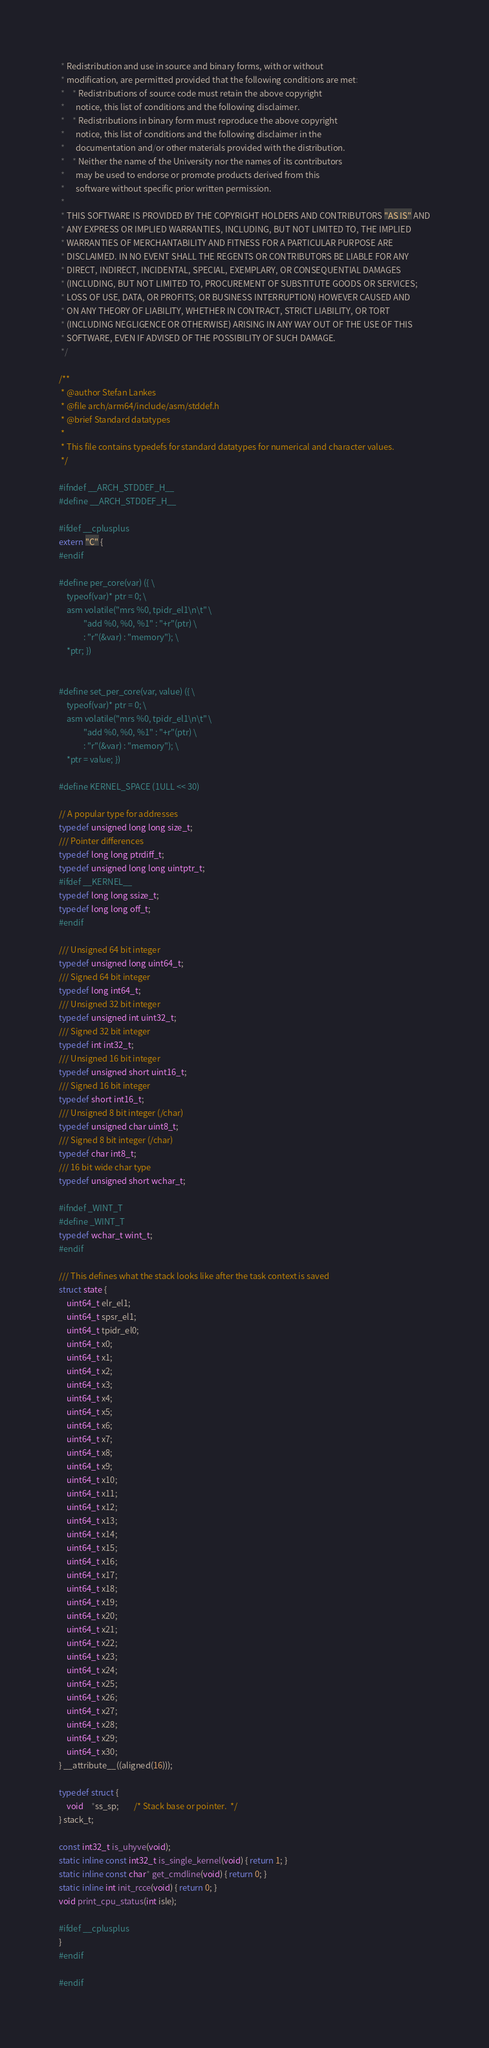<code> <loc_0><loc_0><loc_500><loc_500><_C_> * Redistribution and use in source and binary forms, with or without
 * modification, are permitted provided that the following conditions are met:
 *    * Redistributions of source code must retain the above copyright
 *      notice, this list of conditions and the following disclaimer.
 *    * Redistributions in binary form must reproduce the above copyright
 *      notice, this list of conditions and the following disclaimer in the
 *      documentation and/or other materials provided with the distribution.
 *    * Neither the name of the University nor the names of its contributors
 *      may be used to endorse or promote products derived from this
 *      software without specific prior written permission.
 *
 * THIS SOFTWARE IS PROVIDED BY THE COPYRIGHT HOLDERS AND CONTRIBUTORS "AS IS" AND
 * ANY EXPRESS OR IMPLIED WARRANTIES, INCLUDING, BUT NOT LIMITED TO, THE IMPLIED
 * WARRANTIES OF MERCHANTABILITY AND FITNESS FOR A PARTICULAR PURPOSE ARE
 * DISCLAIMED. IN NO EVENT SHALL THE REGENTS OR CONTRIBUTORS BE LIABLE FOR ANY
 * DIRECT, INDIRECT, INCIDENTAL, SPECIAL, EXEMPLARY, OR CONSEQUENTIAL DAMAGES
 * (INCLUDING, BUT NOT LIMITED TO, PROCUREMENT OF SUBSTITUTE GOODS OR SERVICES;
 * LOSS OF USE, DATA, OR PROFITS; OR BUSINESS INTERRUPTION) HOWEVER CAUSED AND
 * ON ANY THEORY OF LIABILITY, WHETHER IN CONTRACT, STRICT LIABILITY, OR TORT
 * (INCLUDING NEGLIGENCE OR OTHERWISE) ARISING IN ANY WAY OUT OF THE USE OF THIS
 * SOFTWARE, EVEN IF ADVISED OF THE POSSIBILITY OF SUCH DAMAGE.
 */

/**
 * @author Stefan Lankes
 * @file arch/arm64/include/asm/stddef.h
 * @brief Standard datatypes
 *
 * This file contains typedefs for standard datatypes for numerical and character values.
 */

#ifndef __ARCH_STDDEF_H__
#define __ARCH_STDDEF_H__

#ifdef __cplusplus
extern "C" {
#endif

#define per_core(var) ({ \
	typeof(var)* ptr = 0; \
	asm volatile("mrs %0, tpidr_el1\n\t" \
		     "add %0, %0, %1" : "+r"(ptr) \
		     : "r"(&var) : "memory"); \
	*ptr; })


#define set_per_core(var, value) ({ \
	typeof(var)* ptr = 0; \
	asm volatile("mrs %0, tpidr_el1\n\t" \
		     "add %0, %0, %1" : "+r"(ptr) \
		     : "r"(&var) : "memory"); \
	*ptr = value; })

#define KERNEL_SPACE (1ULL << 30)

// A popular type for addresses
typedef unsigned long long size_t;
/// Pointer differences
typedef long long ptrdiff_t;
typedef unsigned long long uintptr_t;
#ifdef __KERNEL__
typedef long long ssize_t;
typedef long long off_t;
#endif

/// Unsigned 64 bit integer
typedef unsigned long uint64_t;
/// Signed 64 bit integer
typedef long int64_t;
/// Unsigned 32 bit integer
typedef unsigned int uint32_t;
/// Signed 32 bit integer
typedef int int32_t;
/// Unsigned 16 bit integer
typedef unsigned short uint16_t;
/// Signed 16 bit integer
typedef short int16_t;
/// Unsigned 8 bit integer (/char)
typedef unsigned char uint8_t;
/// Signed 8 bit integer (/char)
typedef char int8_t;
/// 16 bit wide char type
typedef unsigned short wchar_t;

#ifndef _WINT_T
#define _WINT_T
typedef wchar_t wint_t;
#endif

/// This defines what the stack looks like after the task context is saved
struct state {
	uint64_t elr_el1;
	uint64_t spsr_el1;
	uint64_t tpidr_el0;
	uint64_t x0;
	uint64_t x1;
	uint64_t x2;
	uint64_t x3;
	uint64_t x4;
	uint64_t x5;
	uint64_t x6;
	uint64_t x7;
	uint64_t x8;
	uint64_t x9;
	uint64_t x10;
	uint64_t x11;
	uint64_t x12;
	uint64_t x13;
	uint64_t x14;
	uint64_t x15;
	uint64_t x16;
	uint64_t x17;
	uint64_t x18;
	uint64_t x19;
	uint64_t x20;
	uint64_t x21;
	uint64_t x22;
	uint64_t x23;
	uint64_t x24;
	uint64_t x25;
	uint64_t x26;
	uint64_t x27;
	uint64_t x28;
	uint64_t x29;
	uint64_t x30;
} __attribute__((aligned(16)));

typedef struct {
	void	*ss_sp;		/* Stack base or pointer.  */
} stack_t;

const int32_t is_uhyve(void);
static inline const int32_t is_single_kernel(void) { return 1; }
static inline const char* get_cmdline(void) { return 0; }
static inline int init_rcce(void) { return 0; }
void print_cpu_status(int isle);

#ifdef __cplusplus
}
#endif

#endif
</code> 